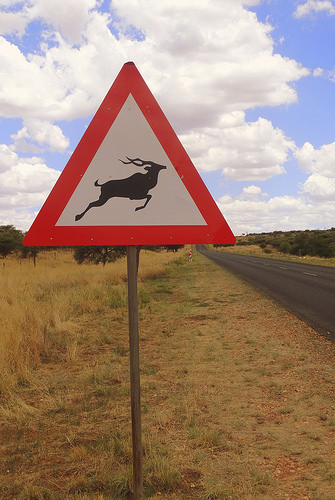<image>
Is the board to the left of the road? Yes. From this viewpoint, the board is positioned to the left side relative to the road. 